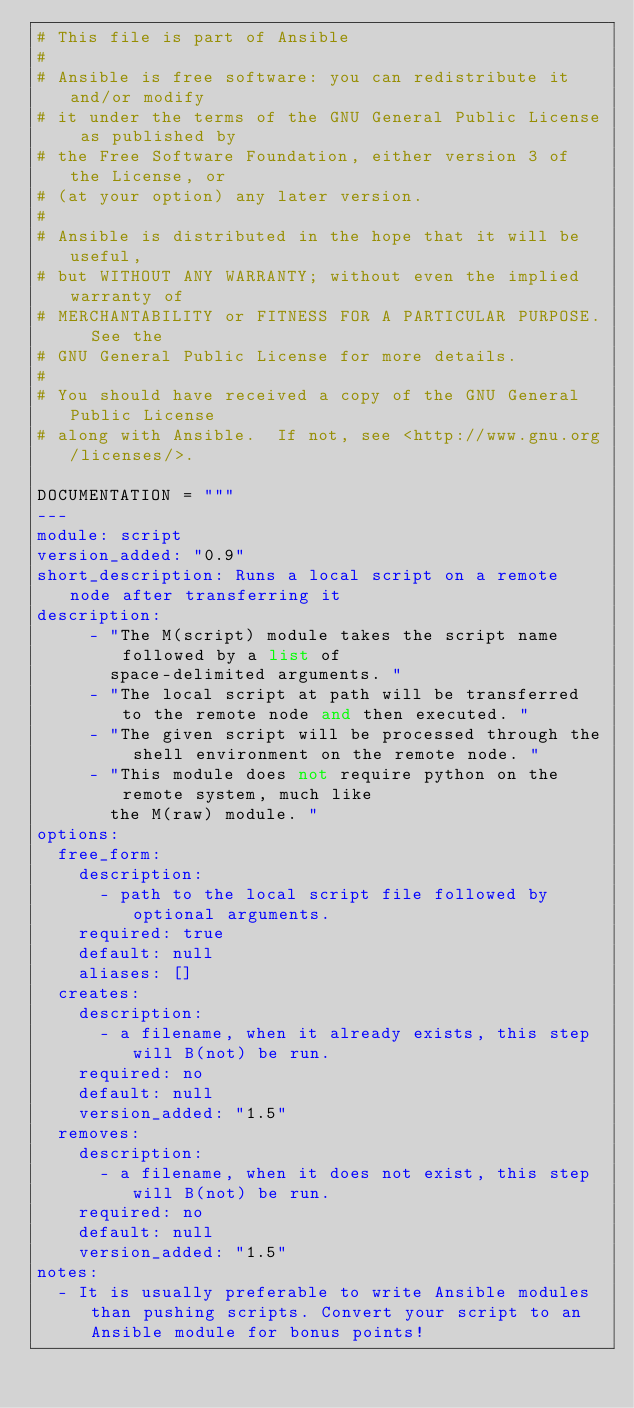Convert code to text. <code><loc_0><loc_0><loc_500><loc_500><_Python_># This file is part of Ansible
#
# Ansible is free software: you can redistribute it and/or modify
# it under the terms of the GNU General Public License as published by
# the Free Software Foundation, either version 3 of the License, or
# (at your option) any later version.
#
# Ansible is distributed in the hope that it will be useful,
# but WITHOUT ANY WARRANTY; without even the implied warranty of
# MERCHANTABILITY or FITNESS FOR A PARTICULAR PURPOSE.  See the
# GNU General Public License for more details.
#
# You should have received a copy of the GNU General Public License
# along with Ansible.  If not, see <http://www.gnu.org/licenses/>.

DOCUMENTATION = """
---
module: script
version_added: "0.9"
short_description: Runs a local script on a remote node after transferring it
description:
     - "The M(script) module takes the script name followed by a list of
       space-delimited arguments. "
     - "The local script at path will be transferred to the remote node and then executed. "
     - "The given script will be processed through the shell environment on the remote node. "
     - "This module does not require python on the remote system, much like
       the M(raw) module. "
options:
  free_form:
    description:
      - path to the local script file followed by optional arguments.
    required: true
    default: null
    aliases: []
  creates:
    description:
      - a filename, when it already exists, this step will B(not) be run.
    required: no
    default: null
    version_added: "1.5"
  removes:
    description:
      - a filename, when it does not exist, this step will B(not) be run.
    required: no
    default: null
    version_added: "1.5"
notes:
  - It is usually preferable to write Ansible modules than pushing scripts. Convert your script to an Ansible module for bonus points!</code> 